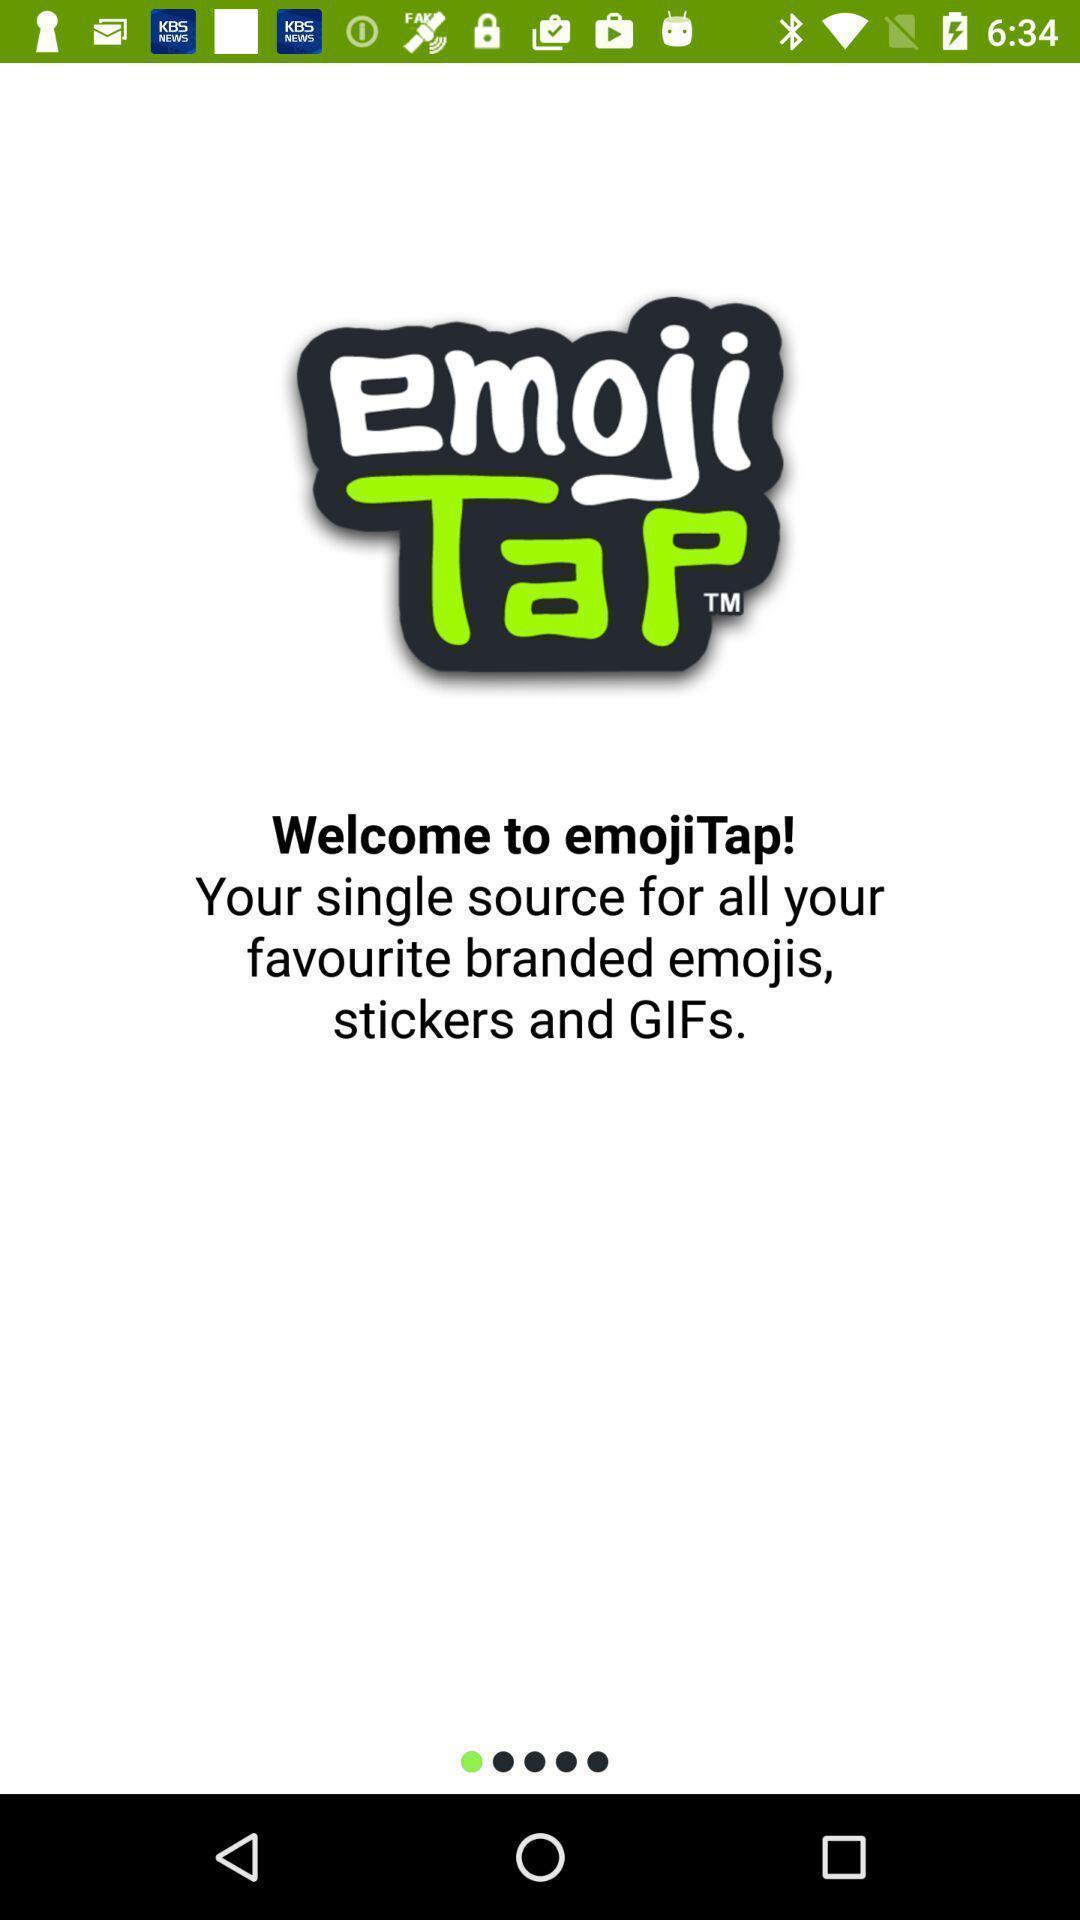Describe this image in words. Welcoming page a emoji tap app. 